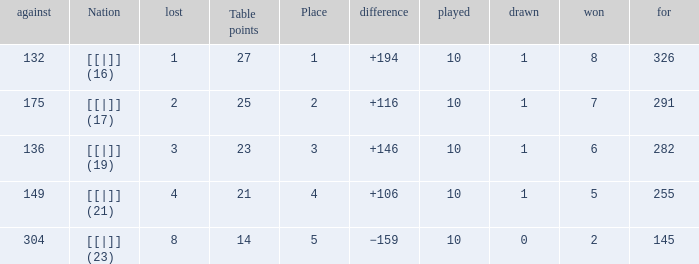 How many games had a deficit of 175?  1.0. 